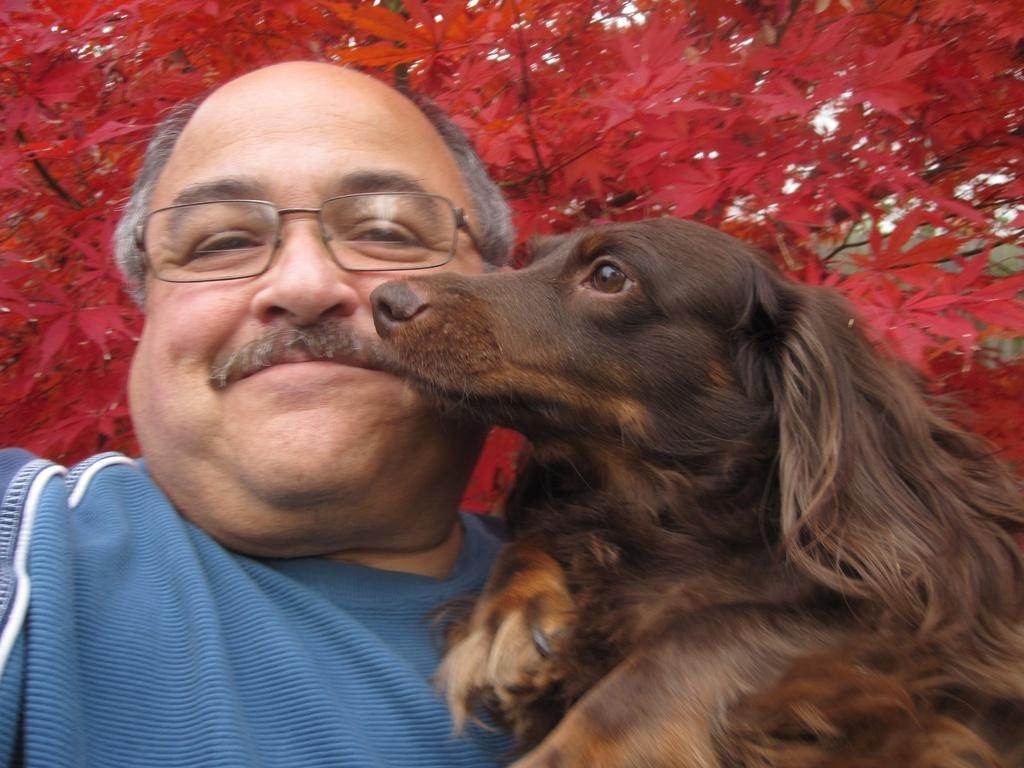What is the main subject in the picture? There is a man in the picture. Can you describe the man's appearance? The man is wearing spectacles. What other living creature is present in the image? There is a dog in the picture. What is the color of the dog? The dog is brown in color. What can be seen in the background of the image? There is a tree in the background of the image. What is the color of the tree? The tree is red in color. Can you tell me how many worms are crawling on the man's shoes in the image? There are no worms present in the image, so it is not possible to determine how many might be crawling on the man's shoes. 